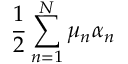<formula> <loc_0><loc_0><loc_500><loc_500>\frac { 1 } { 2 } \sum _ { n = 1 } ^ { N } \mu _ { n } \alpha _ { n }</formula> 